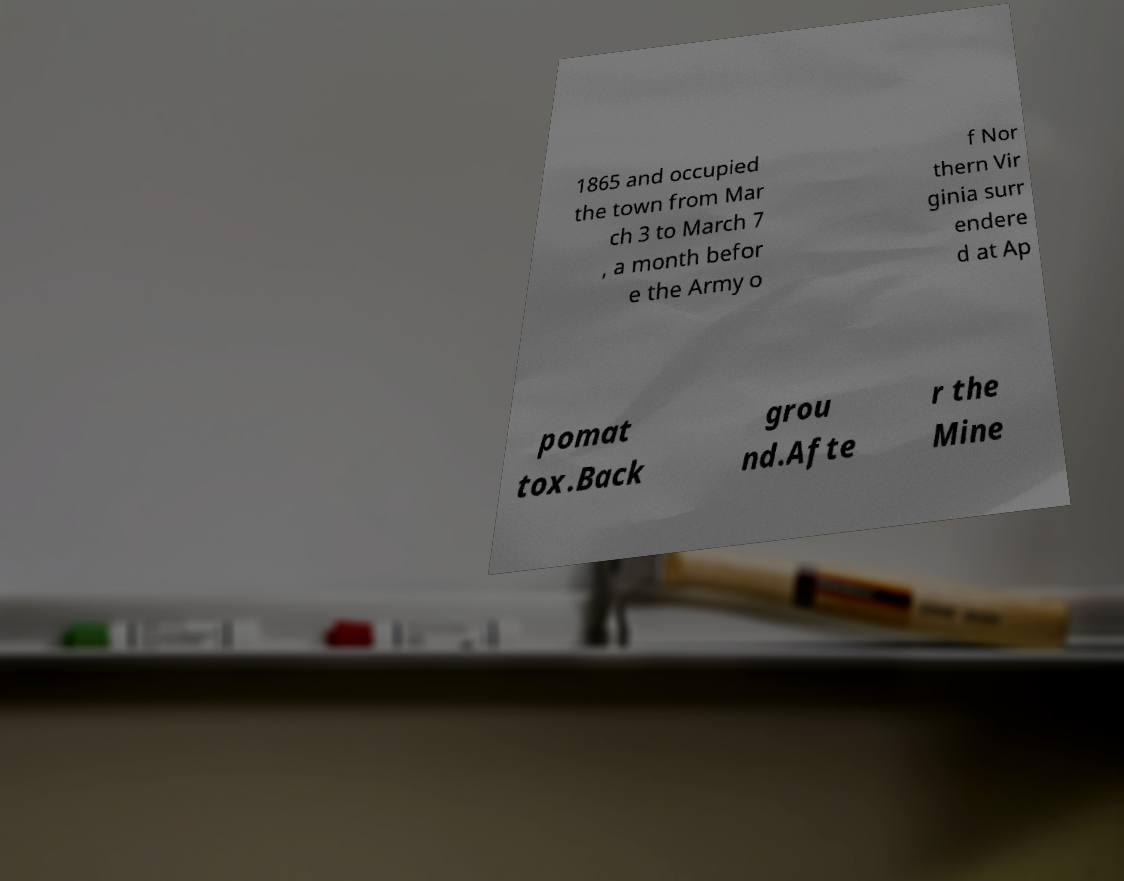Could you assist in decoding the text presented in this image and type it out clearly? 1865 and occupied the town from Mar ch 3 to March 7 , a month befor e the Army o f Nor thern Vir ginia surr endere d at Ap pomat tox.Back grou nd.Afte r the Mine 